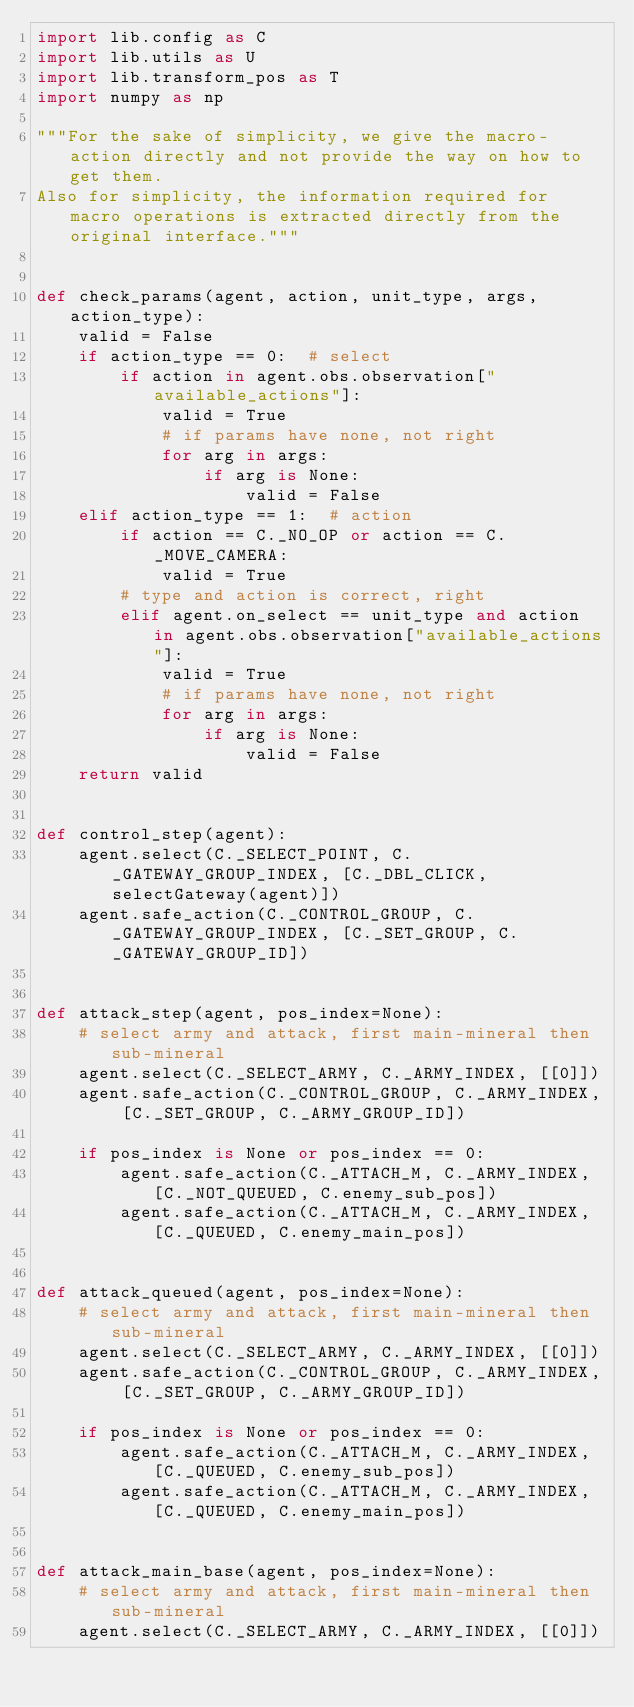<code> <loc_0><loc_0><loc_500><loc_500><_Python_>import lib.config as C
import lib.utils as U
import lib.transform_pos as T
import numpy as np

"""For the sake of simplicity, we give the macro-action directly and not provide the way on how to get them. 
Also for simplicity, the information required for macro operations is extracted directly from the original interface."""


def check_params(agent, action, unit_type, args, action_type):
    valid = False
    if action_type == 0:  # select
        if action in agent.obs.observation["available_actions"]:
            valid = True
            # if params have none, not right
            for arg in args:
                if arg is None:
                    valid = False
    elif action_type == 1:  # action
        if action == C._NO_OP or action == C._MOVE_CAMERA:
            valid = True
        # type and action is correct, right
        elif agent.on_select == unit_type and action in agent.obs.observation["available_actions"]:
            valid = True
            # if params have none, not right
            for arg in args:
                if arg is None:
                    valid = False
    return valid


def control_step(agent):
    agent.select(C._SELECT_POINT, C._GATEWAY_GROUP_INDEX, [C._DBL_CLICK, selectGateway(agent)])
    agent.safe_action(C._CONTROL_GROUP, C._GATEWAY_GROUP_INDEX, [C._SET_GROUP, C._GATEWAY_GROUP_ID])


def attack_step(agent, pos_index=None):
    # select army and attack, first main-mineral then sub-mineral
    agent.select(C._SELECT_ARMY, C._ARMY_INDEX, [[0]])
    agent.safe_action(C._CONTROL_GROUP, C._ARMY_INDEX, [C._SET_GROUP, C._ARMY_GROUP_ID])

    if pos_index is None or pos_index == 0:
        agent.safe_action(C._ATTACH_M, C._ARMY_INDEX, [C._NOT_QUEUED, C.enemy_sub_pos])
        agent.safe_action(C._ATTACH_M, C._ARMY_INDEX, [C._QUEUED, C.enemy_main_pos])


def attack_queued(agent, pos_index=None):
    # select army and attack, first main-mineral then sub-mineral
    agent.select(C._SELECT_ARMY, C._ARMY_INDEX, [[0]])
    agent.safe_action(C._CONTROL_GROUP, C._ARMY_INDEX, [C._SET_GROUP, C._ARMY_GROUP_ID])

    if pos_index is None or pos_index == 0:
        agent.safe_action(C._ATTACH_M, C._ARMY_INDEX, [C._QUEUED, C.enemy_sub_pos])
        agent.safe_action(C._ATTACH_M, C._ARMY_INDEX, [C._QUEUED, C.enemy_main_pos])


def attack_main_base(agent, pos_index=None):
    # select army and attack, first main-mineral then sub-mineral
    agent.select(C._SELECT_ARMY, C._ARMY_INDEX, [[0]])</code> 